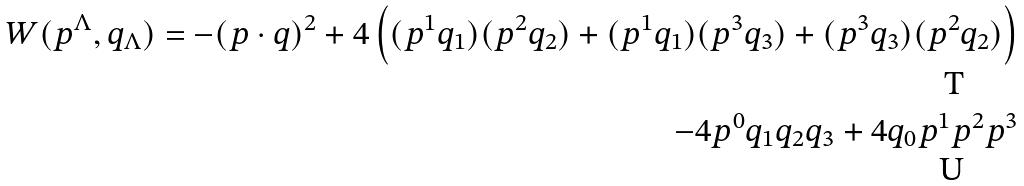Convert formula to latex. <formula><loc_0><loc_0><loc_500><loc_500>W ( p ^ { \Lambda } , q _ { \Lambda } ) = - { ( p \cdot q ) } ^ { 2 } + 4 \left ( ( p ^ { 1 } q _ { 1 } ) ( p ^ { 2 } q _ { 2 } ) + ( p ^ { 1 } q _ { 1 } ) ( p ^ { 3 } q _ { 3 } ) + ( p ^ { 3 } q _ { 3 } ) ( p ^ { 2 } q _ { 2 } ) \right ) \\ - 4 p ^ { 0 } q _ { 1 } q _ { 2 } q _ { 3 } + 4 q _ { 0 } p ^ { 1 } p ^ { 2 } p ^ { 3 }</formula> 